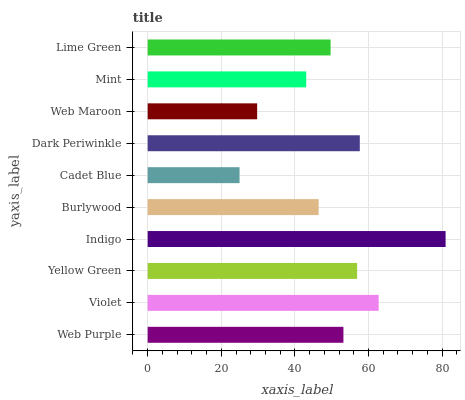Is Cadet Blue the minimum?
Answer yes or no. Yes. Is Indigo the maximum?
Answer yes or no. Yes. Is Violet the minimum?
Answer yes or no. No. Is Violet the maximum?
Answer yes or no. No. Is Violet greater than Web Purple?
Answer yes or no. Yes. Is Web Purple less than Violet?
Answer yes or no. Yes. Is Web Purple greater than Violet?
Answer yes or no. No. Is Violet less than Web Purple?
Answer yes or no. No. Is Web Purple the high median?
Answer yes or no. Yes. Is Lime Green the low median?
Answer yes or no. Yes. Is Indigo the high median?
Answer yes or no. No. Is Web Purple the low median?
Answer yes or no. No. 